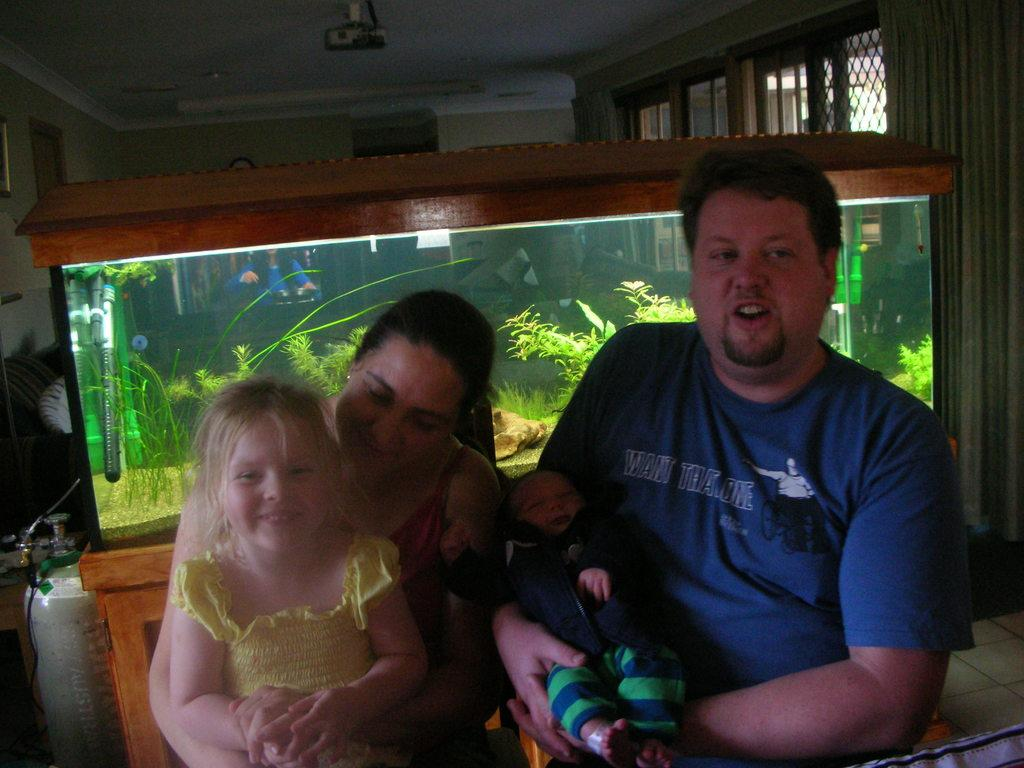What are the persons in the image doing? The persons in the image are sitting on a bench. Can you describe the person holding an object in their hands? One of the persons is holding a baby in their hands. What can be seen in the background of the image? In the background of the image, there is a cylinder, an aquarium, a projector, walls, and windows. What type of juice can be seen on the shelf in the image? There is no shelf or juice present in the image. 